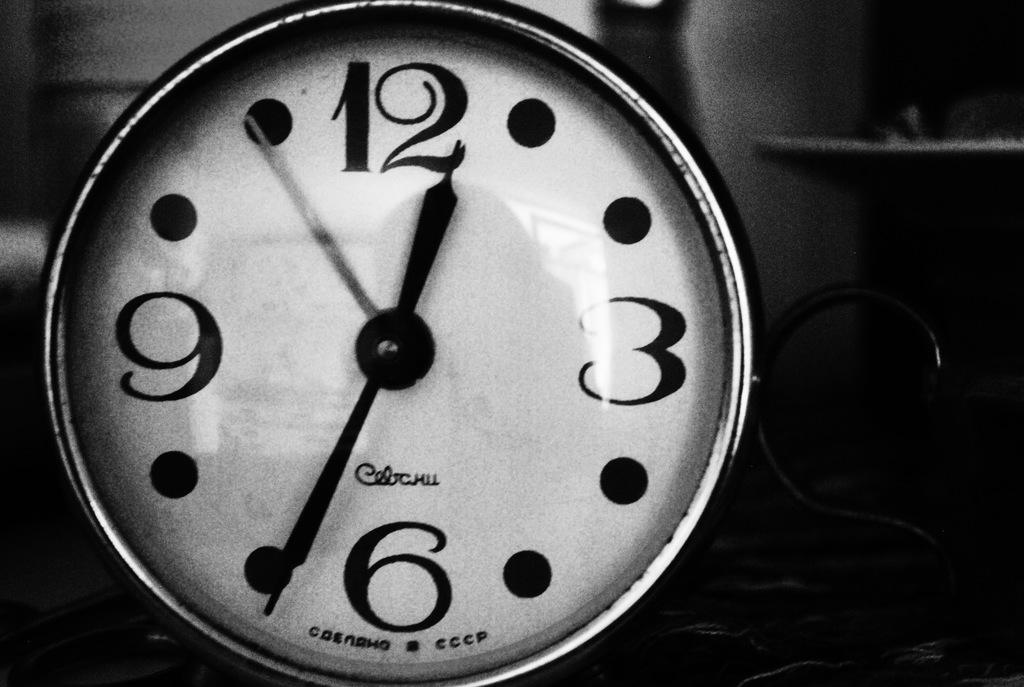Provide a one-sentence caption for the provided image. A white black and metal alarm clock whose time is twelve thirty four. 